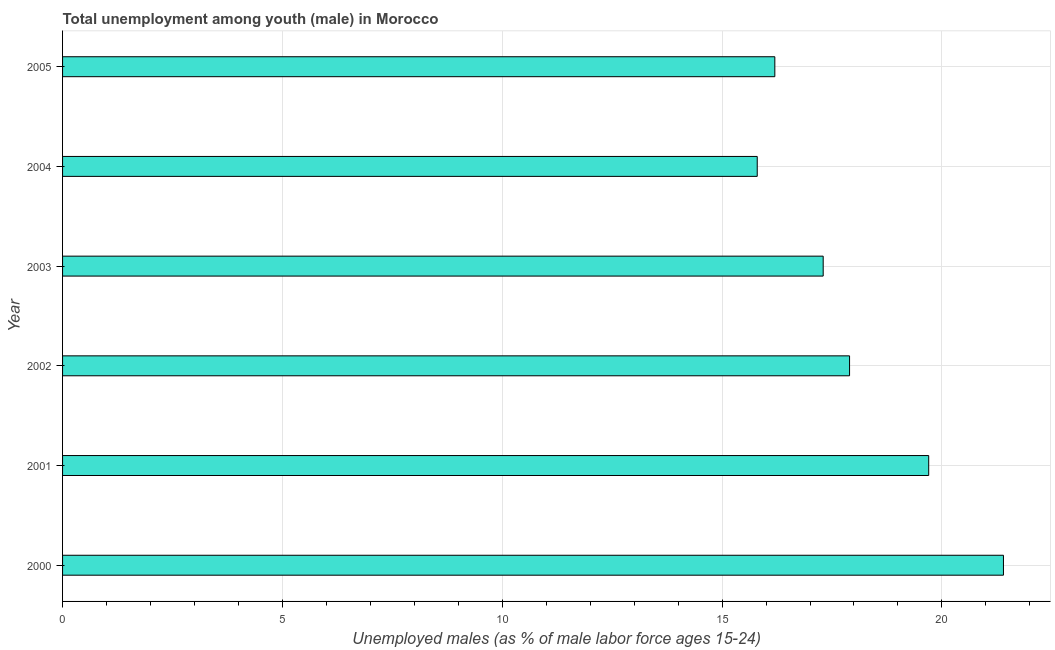Does the graph contain any zero values?
Keep it short and to the point. No. What is the title of the graph?
Your answer should be very brief. Total unemployment among youth (male) in Morocco. What is the label or title of the X-axis?
Make the answer very short. Unemployed males (as % of male labor force ages 15-24). What is the label or title of the Y-axis?
Offer a very short reply. Year. What is the unemployed male youth population in 2003?
Provide a succinct answer. 17.3. Across all years, what is the maximum unemployed male youth population?
Provide a short and direct response. 21.4. Across all years, what is the minimum unemployed male youth population?
Provide a short and direct response. 15.8. In which year was the unemployed male youth population minimum?
Ensure brevity in your answer.  2004. What is the sum of the unemployed male youth population?
Offer a terse response. 108.3. What is the average unemployed male youth population per year?
Offer a very short reply. 18.05. What is the median unemployed male youth population?
Make the answer very short. 17.6. In how many years, is the unemployed male youth population greater than 8 %?
Make the answer very short. 6. What is the ratio of the unemployed male youth population in 2003 to that in 2004?
Provide a succinct answer. 1.09. Is the difference between the unemployed male youth population in 2004 and 2005 greater than the difference between any two years?
Offer a very short reply. No. What is the difference between the highest and the lowest unemployed male youth population?
Make the answer very short. 5.6. How many bars are there?
Provide a short and direct response. 6. How many years are there in the graph?
Give a very brief answer. 6. What is the difference between two consecutive major ticks on the X-axis?
Provide a short and direct response. 5. What is the Unemployed males (as % of male labor force ages 15-24) of 2000?
Your answer should be compact. 21.4. What is the Unemployed males (as % of male labor force ages 15-24) in 2001?
Give a very brief answer. 19.7. What is the Unemployed males (as % of male labor force ages 15-24) in 2002?
Keep it short and to the point. 17.9. What is the Unemployed males (as % of male labor force ages 15-24) in 2003?
Ensure brevity in your answer.  17.3. What is the Unemployed males (as % of male labor force ages 15-24) of 2004?
Ensure brevity in your answer.  15.8. What is the Unemployed males (as % of male labor force ages 15-24) in 2005?
Give a very brief answer. 16.2. What is the difference between the Unemployed males (as % of male labor force ages 15-24) in 2000 and 2003?
Make the answer very short. 4.1. What is the difference between the Unemployed males (as % of male labor force ages 15-24) in 2001 and 2002?
Ensure brevity in your answer.  1.8. What is the difference between the Unemployed males (as % of male labor force ages 15-24) in 2001 and 2003?
Ensure brevity in your answer.  2.4. What is the difference between the Unemployed males (as % of male labor force ages 15-24) in 2002 and 2005?
Offer a terse response. 1.7. What is the difference between the Unemployed males (as % of male labor force ages 15-24) in 2004 and 2005?
Give a very brief answer. -0.4. What is the ratio of the Unemployed males (as % of male labor force ages 15-24) in 2000 to that in 2001?
Provide a succinct answer. 1.09. What is the ratio of the Unemployed males (as % of male labor force ages 15-24) in 2000 to that in 2002?
Offer a terse response. 1.2. What is the ratio of the Unemployed males (as % of male labor force ages 15-24) in 2000 to that in 2003?
Provide a succinct answer. 1.24. What is the ratio of the Unemployed males (as % of male labor force ages 15-24) in 2000 to that in 2004?
Ensure brevity in your answer.  1.35. What is the ratio of the Unemployed males (as % of male labor force ages 15-24) in 2000 to that in 2005?
Make the answer very short. 1.32. What is the ratio of the Unemployed males (as % of male labor force ages 15-24) in 2001 to that in 2002?
Offer a terse response. 1.1. What is the ratio of the Unemployed males (as % of male labor force ages 15-24) in 2001 to that in 2003?
Make the answer very short. 1.14. What is the ratio of the Unemployed males (as % of male labor force ages 15-24) in 2001 to that in 2004?
Offer a terse response. 1.25. What is the ratio of the Unemployed males (as % of male labor force ages 15-24) in 2001 to that in 2005?
Ensure brevity in your answer.  1.22. What is the ratio of the Unemployed males (as % of male labor force ages 15-24) in 2002 to that in 2003?
Offer a very short reply. 1.03. What is the ratio of the Unemployed males (as % of male labor force ages 15-24) in 2002 to that in 2004?
Your response must be concise. 1.13. What is the ratio of the Unemployed males (as % of male labor force ages 15-24) in 2002 to that in 2005?
Provide a succinct answer. 1.1. What is the ratio of the Unemployed males (as % of male labor force ages 15-24) in 2003 to that in 2004?
Provide a short and direct response. 1.09. What is the ratio of the Unemployed males (as % of male labor force ages 15-24) in 2003 to that in 2005?
Ensure brevity in your answer.  1.07. 